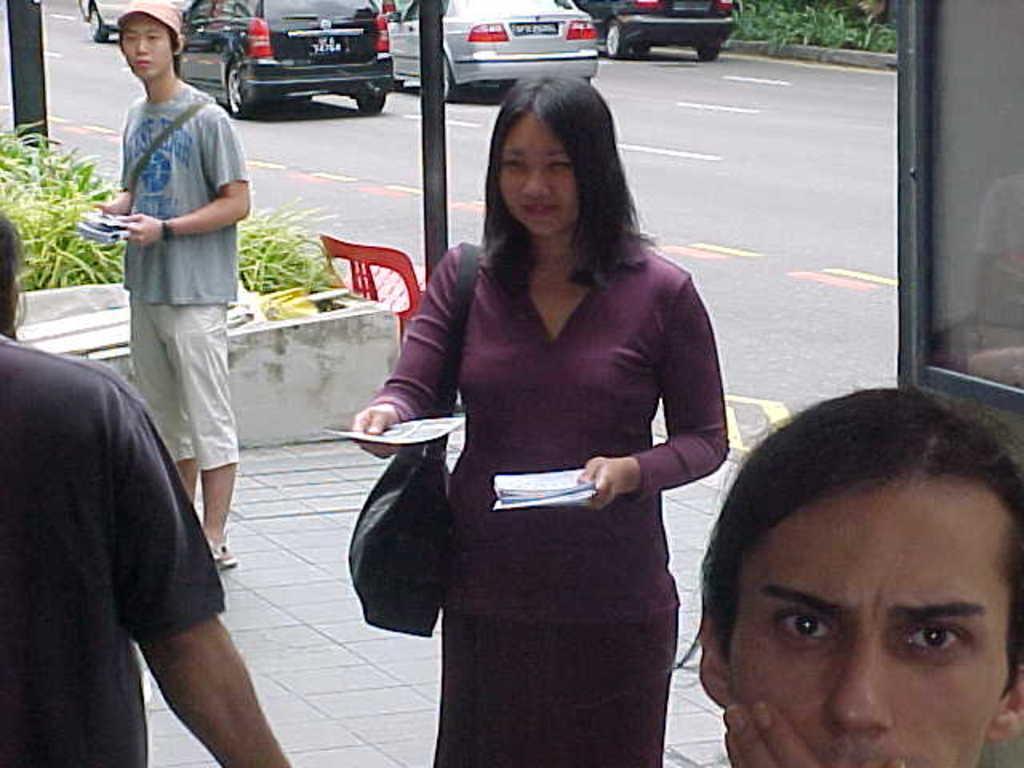Could you give a brief overview of what you see in this image? In the center of the image there is a lady holding papers in her hand. In the background of the image there are cars on the road. There is a person to the right side of the image. To the left side of the image there are plants. In the background of the image there is a person. to the left side of the image there is another person. 